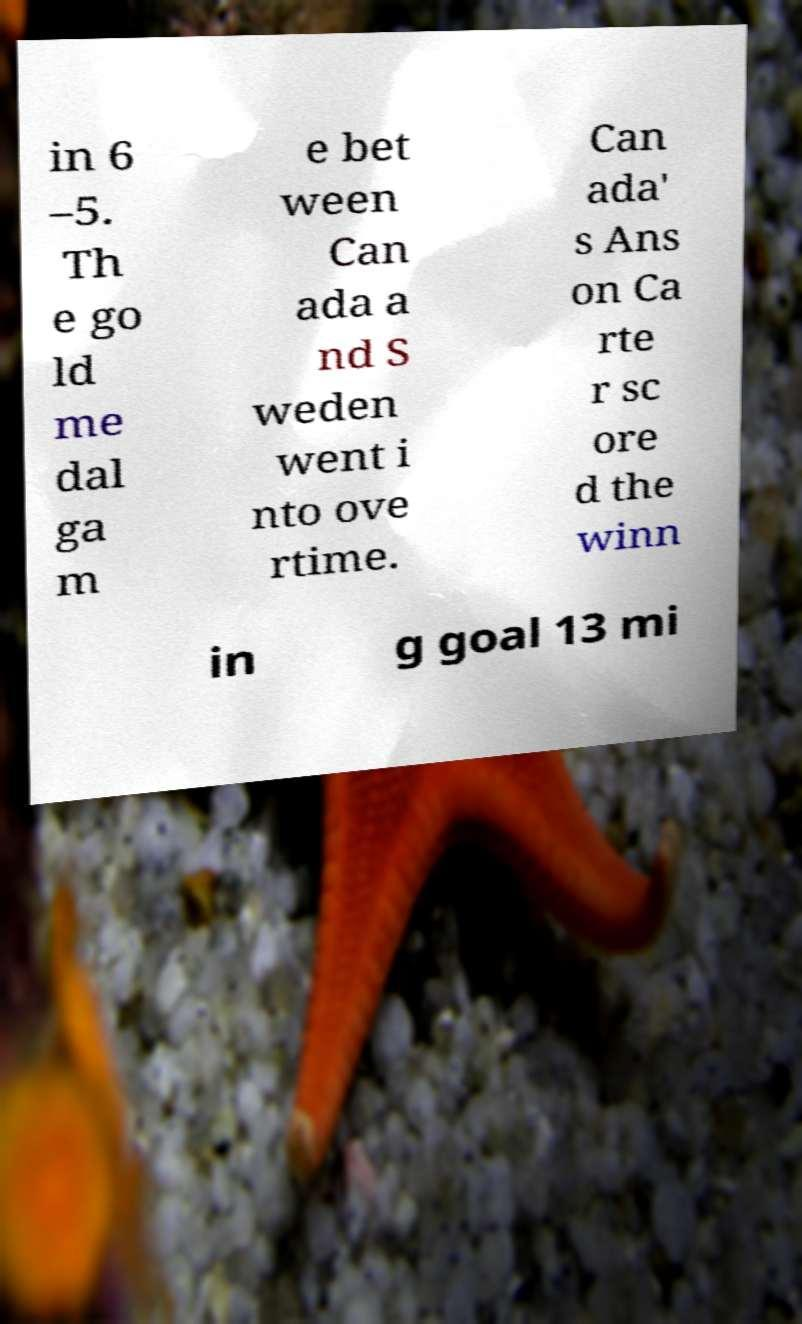Please identify and transcribe the text found in this image. in 6 –5. Th e go ld me dal ga m e bet ween Can ada a nd S weden went i nto ove rtime. Can ada' s Ans on Ca rte r sc ore d the winn in g goal 13 mi 